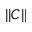Convert formula to latex. <formula><loc_0><loc_0><loc_500><loc_500>| | C | |</formula> 